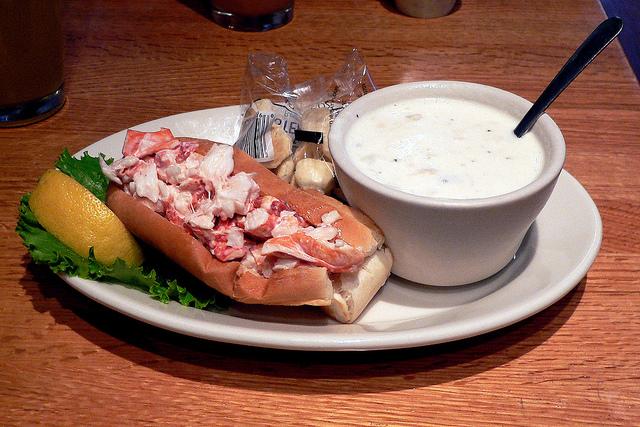Is this a sandwich?
Quick response, please. Yes. What utensil is on the plate?
Answer briefly. Spoon. What kinds of foods can be seen?
Concise answer only. Seafood. What Kind of topping is in the sandwich?
Write a very short answer. Lobster. Is the plate on a placemat?
Short answer required. No. What is there in a cup?
Be succinct. Soup. Is this seafood?
Keep it brief. Yes. What is in the bowl?
Concise answer only. Soup. 